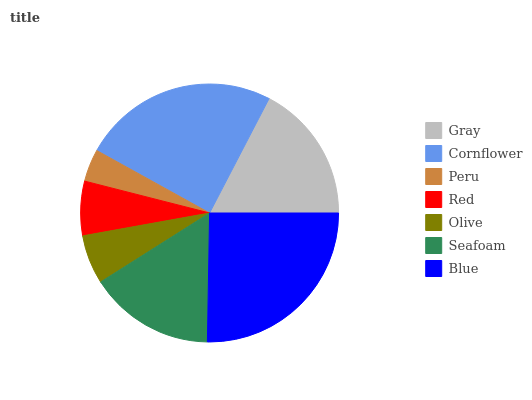Is Peru the minimum?
Answer yes or no. Yes. Is Blue the maximum?
Answer yes or no. Yes. Is Cornflower the minimum?
Answer yes or no. No. Is Cornflower the maximum?
Answer yes or no. No. Is Cornflower greater than Gray?
Answer yes or no. Yes. Is Gray less than Cornflower?
Answer yes or no. Yes. Is Gray greater than Cornflower?
Answer yes or no. No. Is Cornflower less than Gray?
Answer yes or no. No. Is Seafoam the high median?
Answer yes or no. Yes. Is Seafoam the low median?
Answer yes or no. Yes. Is Cornflower the high median?
Answer yes or no. No. Is Cornflower the low median?
Answer yes or no. No. 